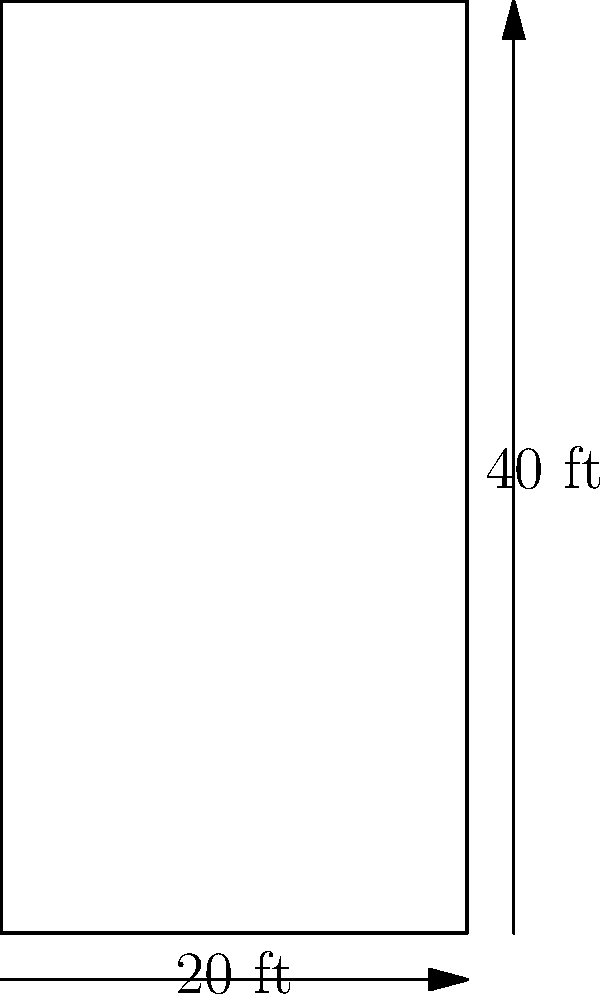A standard racquetball court has rectangular dimensions as shown in the diagram. If you need to calculate the amount of flooring material required to cover the court, what would be the total area in square feet? To calculate the area of the racquetball court, we need to follow these steps:

1. Identify the length and width of the court:
   - Length = 40 ft
   - Width = 20 ft

2. Use the formula for the area of a rectangle:
   $$ A = l \times w $$
   Where $A$ is the area, $l$ is the length, and $w$ is the width.

3. Substitute the values into the formula:
   $$ A = 40 \text{ ft} \times 20 \text{ ft} $$

4. Perform the multiplication:
   $$ A = 800 \text{ ft}^2 $$

Therefore, the total area of the racquetball court is 800 square feet.
Answer: 800 ft² 